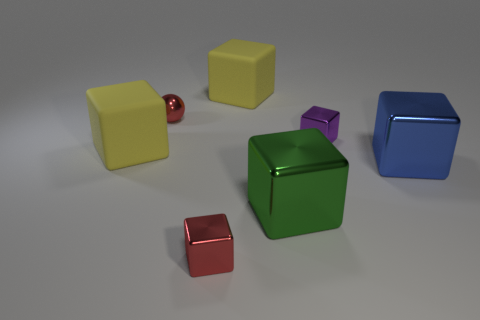Subtract all green cubes. How many cubes are left? 5 Add 1 big blue blocks. How many objects exist? 8 Subtract all yellow blocks. How many blocks are left? 4 Subtract 2 blocks. How many blocks are left? 4 Subtract all brown spheres. How many yellow cubes are left? 2 Add 5 large yellow objects. How many large yellow objects exist? 7 Subtract 0 yellow spheres. How many objects are left? 7 Subtract all cubes. How many objects are left? 1 Subtract all green balls. Subtract all red cubes. How many balls are left? 1 Subtract all yellow things. Subtract all tiny purple objects. How many objects are left? 4 